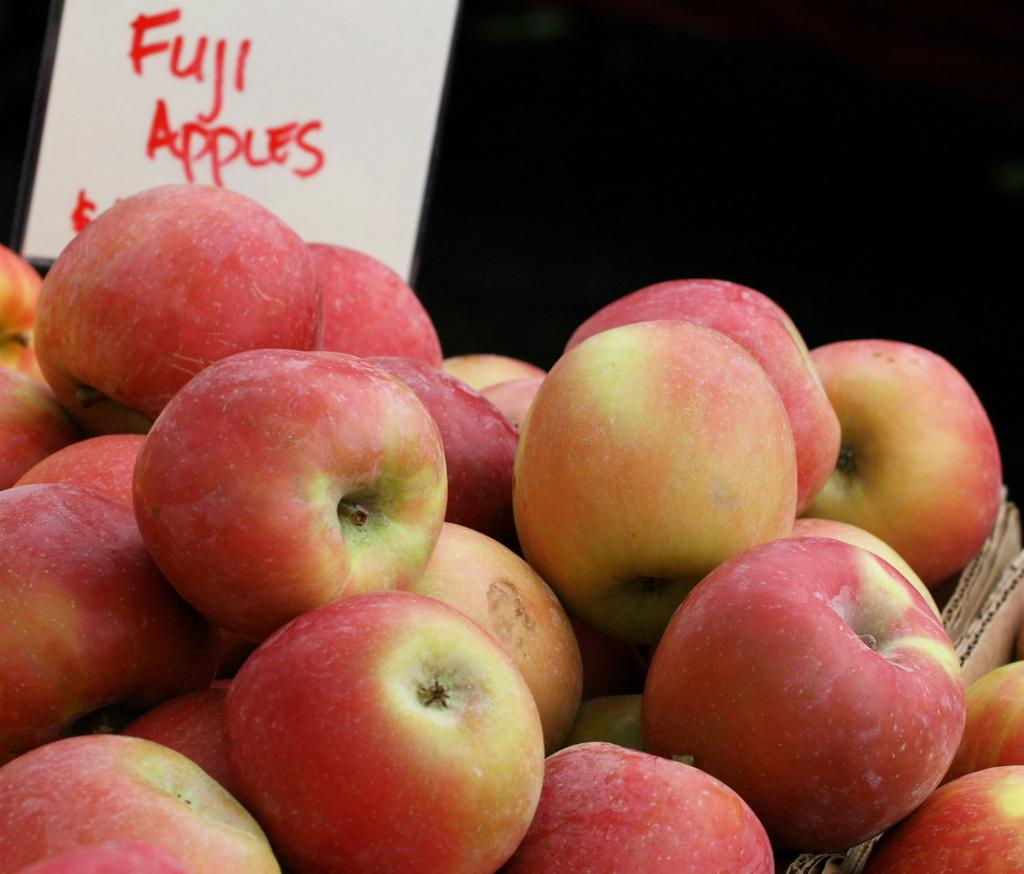What is the color of the background in the image? The background of the image is dark. What type of food items are present in the image? There are fruits in the image, specifically apples. What material are the pieces in the image made of? The pieces in the image are made of cardboard. Is there any written information in the image? Yes, there is a paper note in the image. How far away is the property from the apples in the image? There is no property present in the image, so it is not possible to determine the distance between it and the apples. 